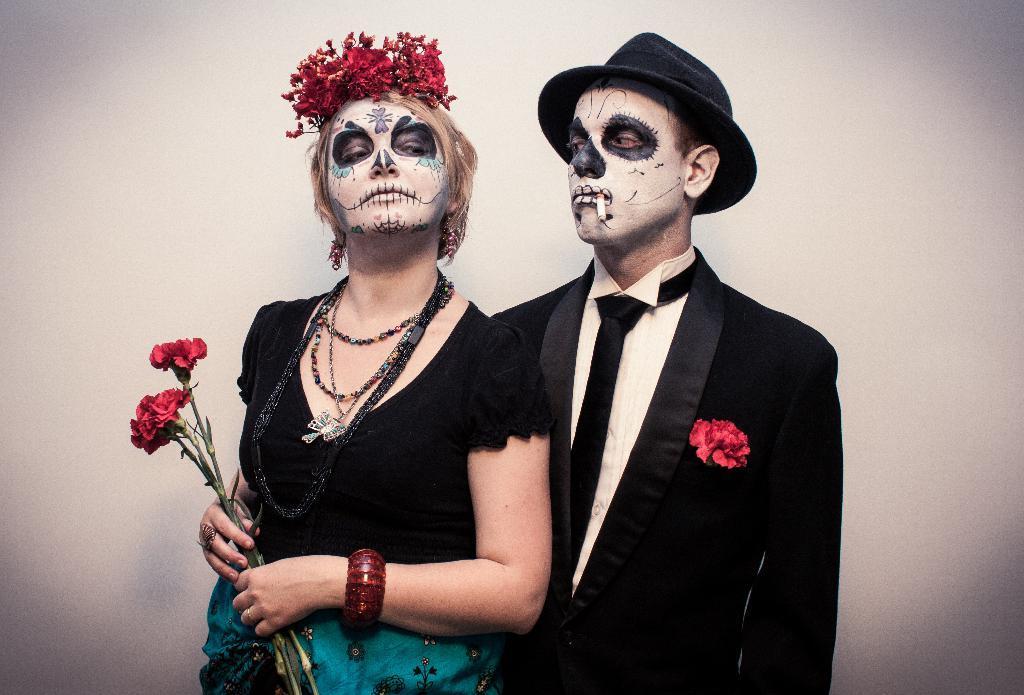Can you describe this image briefly? Here we can see two people. On their faces there is a painting. This woman is holding flowers. Background there is a wall. This person is holding a cigar in his mouth and looking at this girl. 